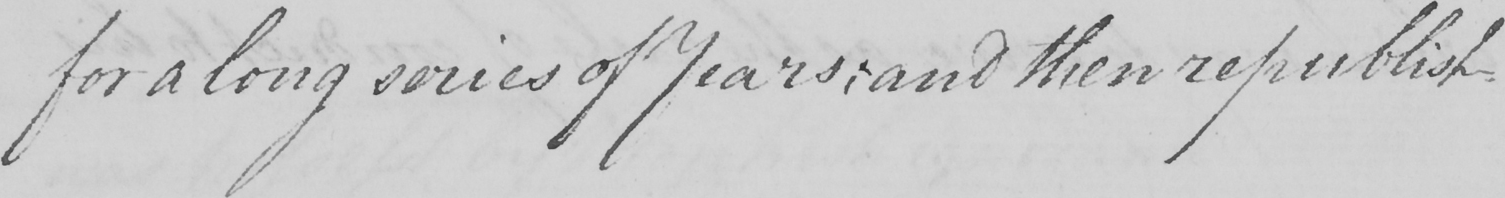Transcribe the text shown in this historical manuscript line. for a long series of Years ; and then republish- 